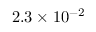<formula> <loc_0><loc_0><loc_500><loc_500>2 . 3 \times 1 0 ^ { - 2 }</formula> 